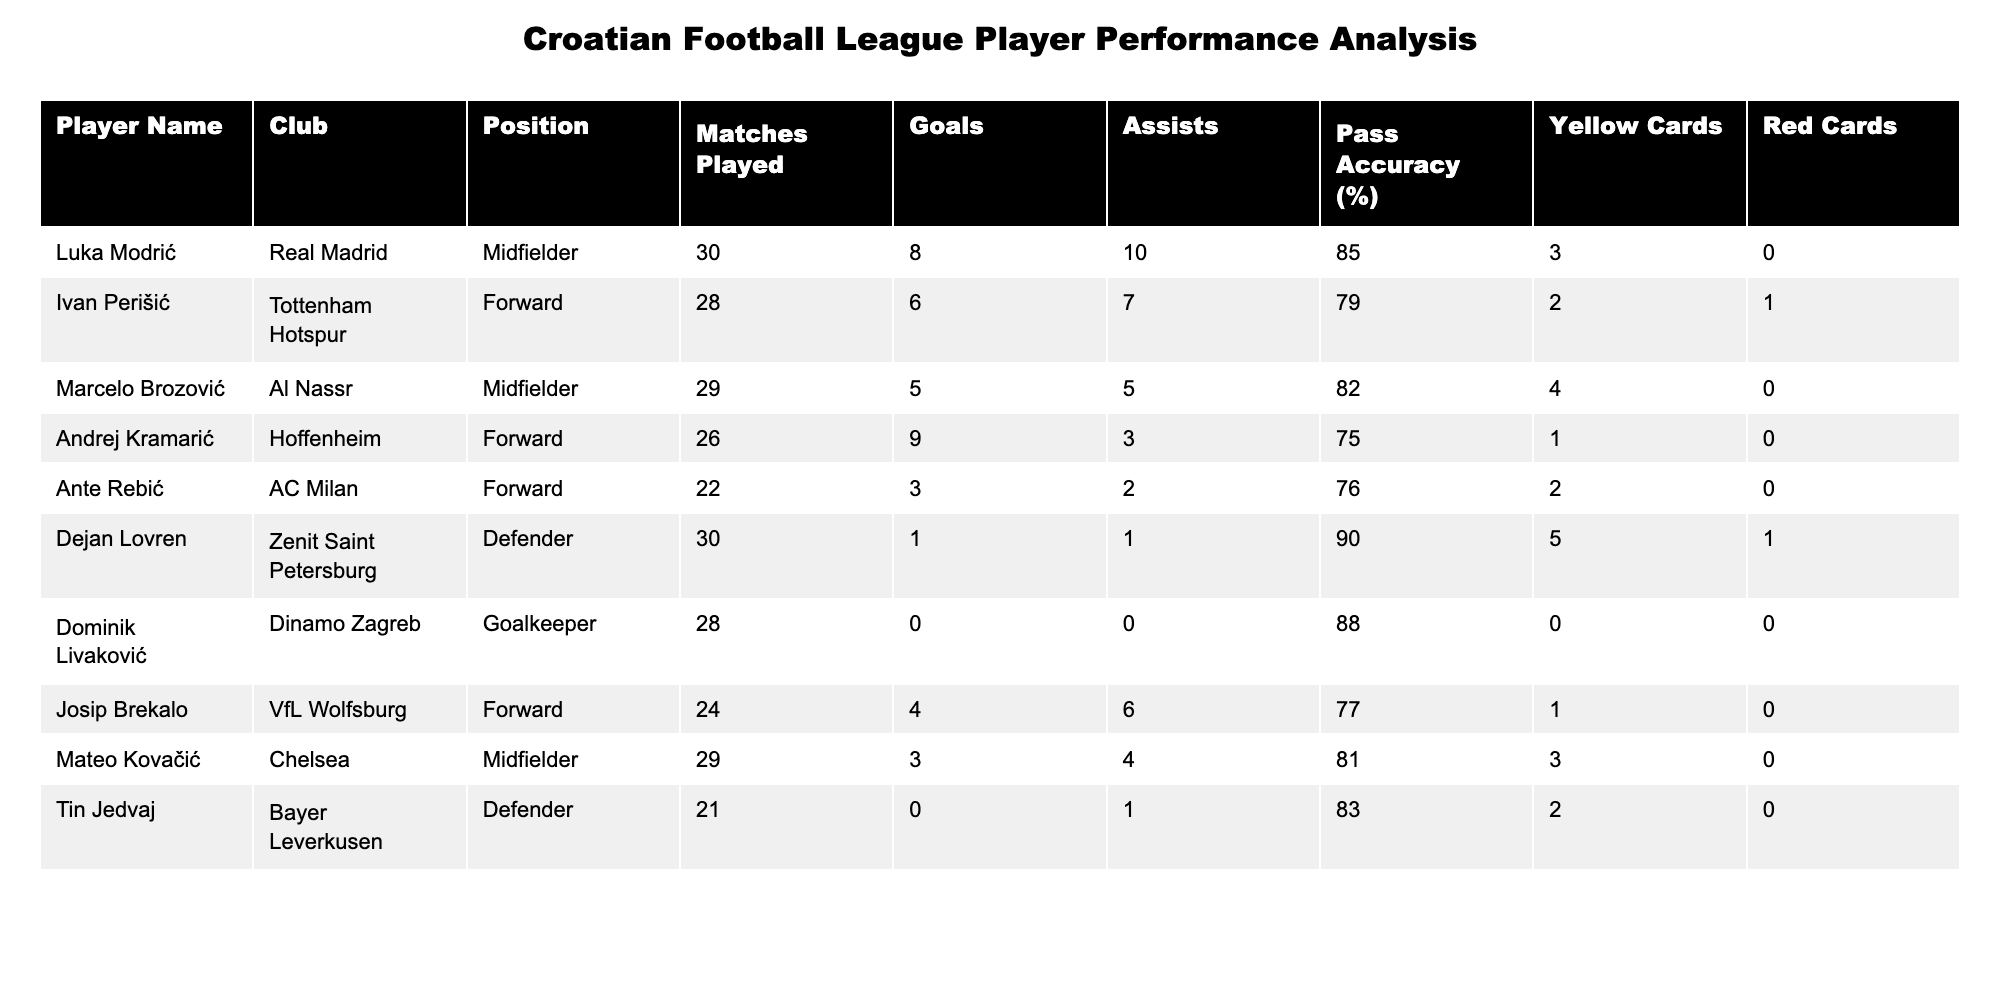What is the total number of goals scored by Croatian players in the league this season? To find the total number of goals, sum all the goals scored by each player: 8 (Modrić) + 6 (Perišić) + 5 (Brozović) + 9 (Kramarić) + 3 (Rebić) + 1 (Lovren) + 0 (Livaković) + 4 (Brekalo) + 3 (Kovačić) + 0 (Jedvaj) = 35.
Answer: 35 Which player has the highest pass accuracy? By checking the "Pass Accuracy (%)" column, I can see that Dejan Lovren has the highest pass accuracy of 90%.
Answer: 90% How many assists did Ivan Perišić provide? Referring to the "Assists" column, I find Ivan Perišić's assists, which is 7.
Answer: 7 What is the average number of yellow cards received by the defenders? First, identify the defenders: Dejan Lovren (5 yellow cards), Tin Jedvaj (2 yellow cards). The sum is 5 + 2 = 7. There are 2 defenders, so the average is 7 / 2 = 3.5.
Answer: 3.5 Is it true that Mateo Kovačić has more assists than goals? For Mateo Kovačić, he has 3 goals and 4 assists. Since 4 is greater than 3, the statement is true.
Answer: Yes Which player received the most yellow cards? By checking the "Yellow Cards" column, Dejan Lovren has the most with 5 yellow cards.
Answer: 5 What is the total number of matches played by forwards? Identify the forwards: Ivan Perišić (28), Andrej Kramarić (26), Ante Rebić (22), Josip Brekalo (24). The sum is 28 + 26 + 22 + 24 = 100.
Answer: 100 Which player has the lowest number of goals? Looking at the "Goals" column, Ante Rebić has the lowest number, which is 3.
Answer: 3 How many players have scored 5 or more goals? Checking the goals, Luka Modrić (8), Andrej Kramarić (9) both scored 5 or more goals, so there are 3 players: Modrić, Kramarić, and Brozović.
Answer: 3 What is the total number of goals and assists by Dominik Livaković combined? Dominik Livaković has 0 goals and 0 assists. So the total is 0 + 0 = 0.
Answer: 0 